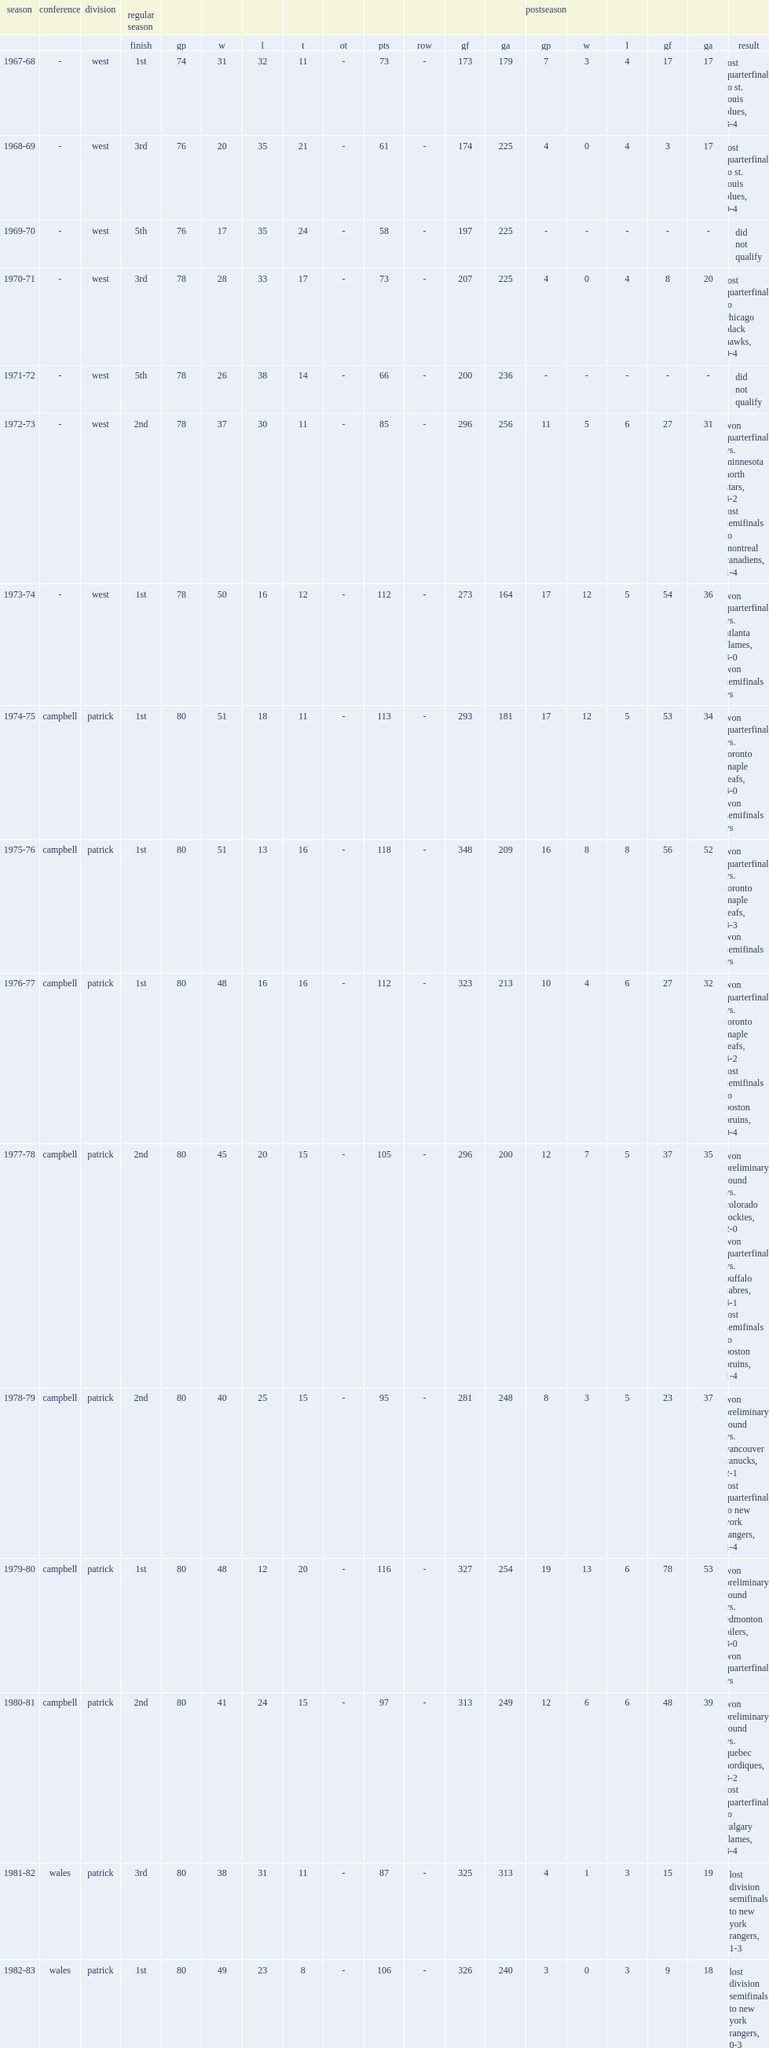Which season in philadelphia flyers was the flyers' 17th season? 1983-84. 